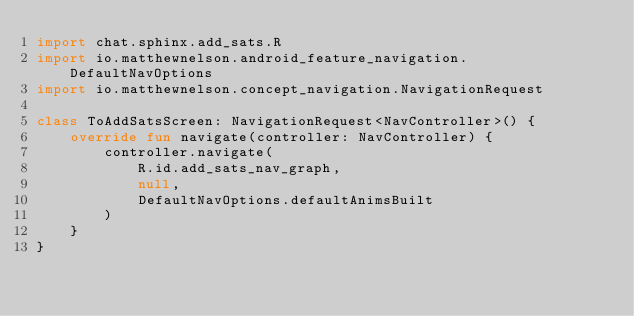Convert code to text. <code><loc_0><loc_0><loc_500><loc_500><_Kotlin_>import chat.sphinx.add_sats.R
import io.matthewnelson.android_feature_navigation.DefaultNavOptions
import io.matthewnelson.concept_navigation.NavigationRequest

class ToAddSatsScreen: NavigationRequest<NavController>() {
    override fun navigate(controller: NavController) {
        controller.navigate(
            R.id.add_sats_nav_graph,
            null,
            DefaultNavOptions.defaultAnimsBuilt
        )
    }
}
</code> 